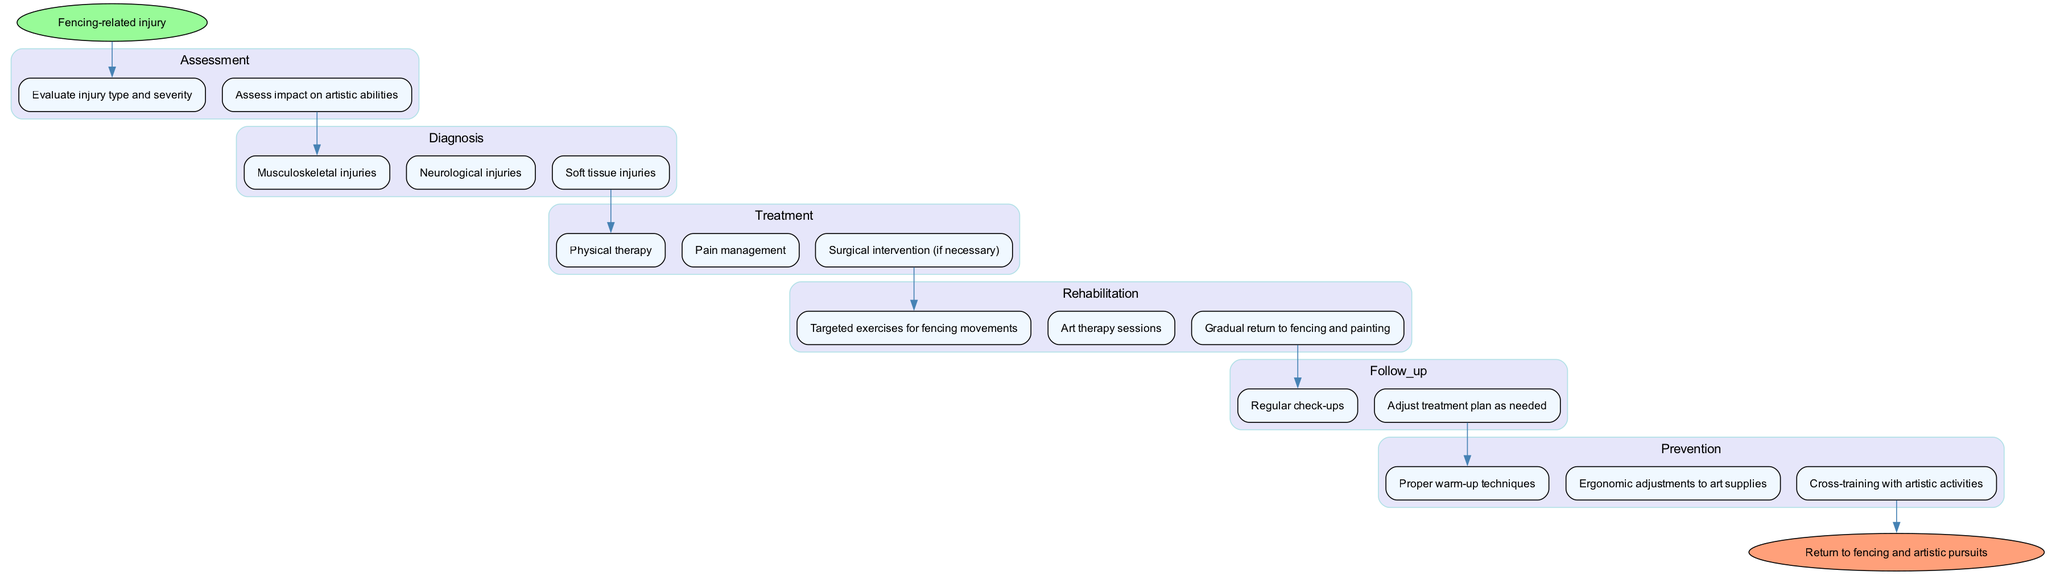What is the starting point of the clinical pathway? The starting point is the "Fencing-related injury" node, which indicates the initial situation prompting the clinical pathway to be followed.
Answer: Fencing-related injury How many steps are in the treatment phase? In the treatment phase, there are three steps listed: "Physical therapy," "Pain management," and "Surgical intervention (if necessary)."
Answer: 3 Which assessment step directly precedes the diagnosis of neurological injuries? The assessment step that directly precedes the diagnosis of neurological injuries is "Assess impact on artistic abilities," as it is linked sequentially before reaching the diagnosis.
Answer: Assess impact on artistic abilities What is the end point of the clinical pathway? The end point is specified as "Return to fencing and artistic pursuits," indicating the desired final outcome of the clinical pathway.
Answer: Return to fencing and artistic pursuits In the rehabilitation phase, which activity focuses specifically on artistic expression? The activity focused specifically on artistic expression in the rehabilitation phase is "Art therapy sessions," which integrates creativity into the recovery process.
Answer: Art therapy sessions How does the follow-up phase interact with the prevention phase? The follow-up phase interacts with the prevention phase by including "Adjust treatment plan as needed," which suggests ongoing evaluations, leading into preventive measures to avoid future injuries.
Answer: Adjust treatment plan as needed In the diagnosis phase, which type of injury is not a soft tissue injury? The type of injury that is not a soft tissue injury in the diagnosis phase is "Musculoskeletal injuries," as it is categorized differently.
Answer: Musculoskeletal injuries What are the nodes included in the assessment phase? The nodes in the assessment phase include "Evaluate injury type and severity" and "Assess impact on artistic abilities," representing the evaluations made after the injury occurs.
Answer: Evaluate injury type and severity; Assess impact on artistic abilities How many edges are in the prevention phase? There are three edges leading from the prevention phase to the end of the pathway, signifying the prevention steps leading to the final outcome.
Answer: 3 